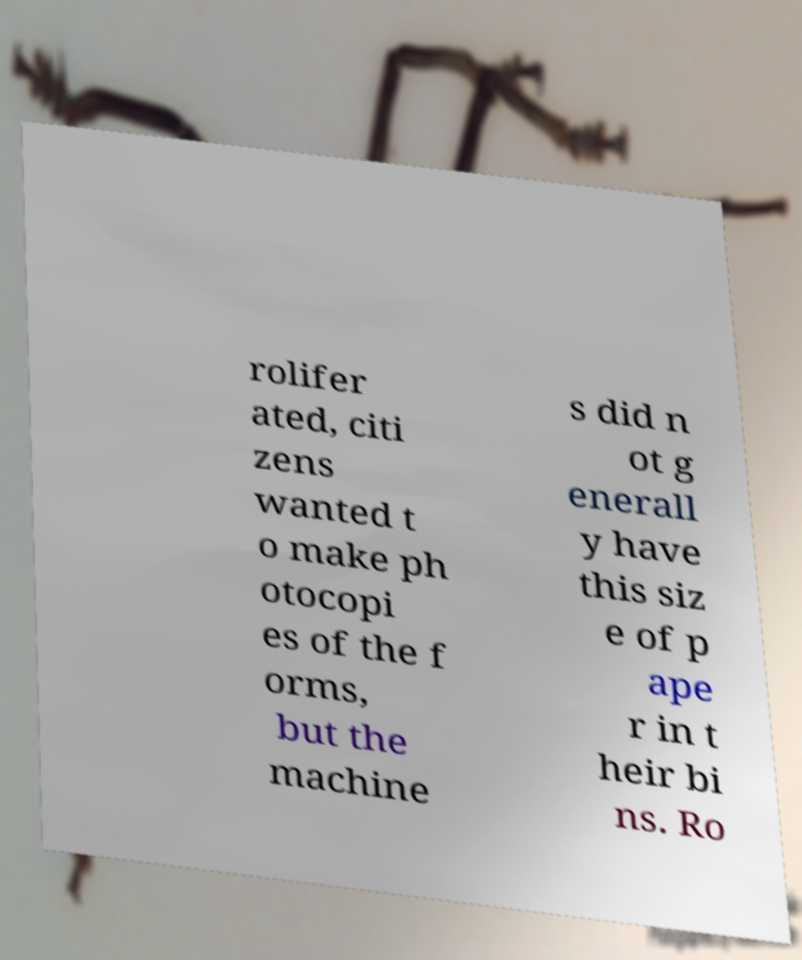Please read and relay the text visible in this image. What does it say? rolifer ated, citi zens wanted t o make ph otocopi es of the f orms, but the machine s did n ot g enerall y have this siz e of p ape r in t heir bi ns. Ro 